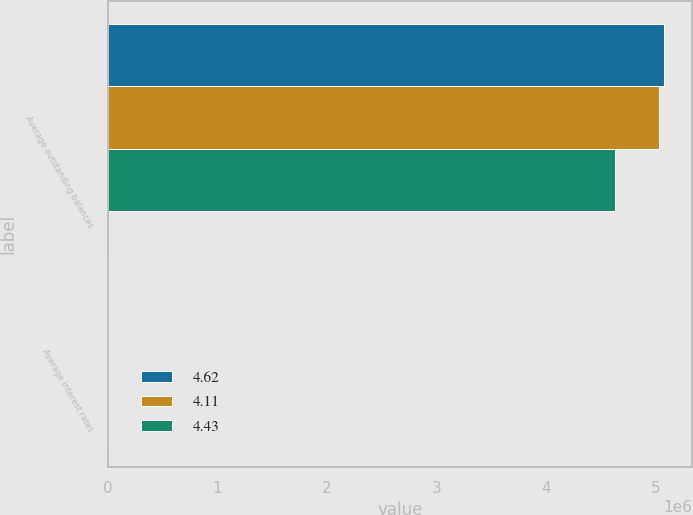Convert chart to OTSL. <chart><loc_0><loc_0><loc_500><loc_500><stacked_bar_chart><ecel><fcel>Average outstanding balances<fcel>Average interest rates<nl><fcel>4.62<fcel>5.08166e+06<fcel>4.11<nl><fcel>4.11<fcel>5.03053e+06<fcel>4.43<nl><fcel>4.43<fcel>4.62844e+06<fcel>4.62<nl></chart> 